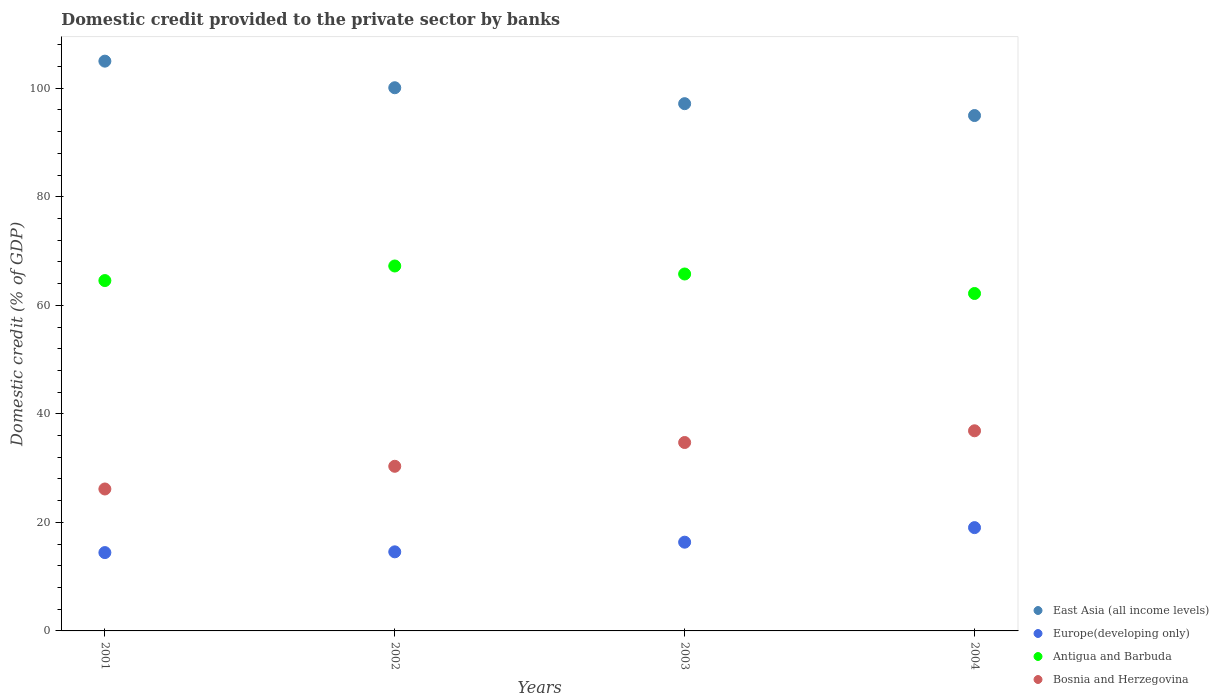Is the number of dotlines equal to the number of legend labels?
Keep it short and to the point. Yes. What is the domestic credit provided to the private sector by banks in East Asia (all income levels) in 2001?
Give a very brief answer. 104.99. Across all years, what is the maximum domestic credit provided to the private sector by banks in Bosnia and Herzegovina?
Keep it short and to the point. 36.88. Across all years, what is the minimum domestic credit provided to the private sector by banks in Europe(developing only)?
Provide a succinct answer. 14.43. In which year was the domestic credit provided to the private sector by banks in East Asia (all income levels) maximum?
Ensure brevity in your answer.  2001. In which year was the domestic credit provided to the private sector by banks in Europe(developing only) minimum?
Keep it short and to the point. 2001. What is the total domestic credit provided to the private sector by banks in Antigua and Barbuda in the graph?
Offer a terse response. 259.74. What is the difference between the domestic credit provided to the private sector by banks in Europe(developing only) in 2002 and that in 2004?
Provide a short and direct response. -4.46. What is the difference between the domestic credit provided to the private sector by banks in Antigua and Barbuda in 2004 and the domestic credit provided to the private sector by banks in Europe(developing only) in 2001?
Your response must be concise. 47.74. What is the average domestic credit provided to the private sector by banks in East Asia (all income levels) per year?
Give a very brief answer. 99.3. In the year 2001, what is the difference between the domestic credit provided to the private sector by banks in Bosnia and Herzegovina and domestic credit provided to the private sector by banks in Europe(developing only)?
Your answer should be very brief. 11.72. In how many years, is the domestic credit provided to the private sector by banks in Bosnia and Herzegovina greater than 40 %?
Provide a short and direct response. 0. What is the ratio of the domestic credit provided to the private sector by banks in Europe(developing only) in 2002 to that in 2004?
Ensure brevity in your answer.  0.77. Is the domestic credit provided to the private sector by banks in Europe(developing only) in 2001 less than that in 2004?
Your answer should be very brief. Yes. Is the difference between the domestic credit provided to the private sector by banks in Bosnia and Herzegovina in 2001 and 2003 greater than the difference between the domestic credit provided to the private sector by banks in Europe(developing only) in 2001 and 2003?
Your answer should be compact. No. What is the difference between the highest and the second highest domestic credit provided to the private sector by banks in East Asia (all income levels)?
Give a very brief answer. 4.9. What is the difference between the highest and the lowest domestic credit provided to the private sector by banks in Europe(developing only)?
Keep it short and to the point. 4.6. Does the domestic credit provided to the private sector by banks in East Asia (all income levels) monotonically increase over the years?
Give a very brief answer. No. Is the domestic credit provided to the private sector by banks in Antigua and Barbuda strictly less than the domestic credit provided to the private sector by banks in Bosnia and Herzegovina over the years?
Keep it short and to the point. No. Are the values on the major ticks of Y-axis written in scientific E-notation?
Give a very brief answer. No. Does the graph contain any zero values?
Make the answer very short. No. Does the graph contain grids?
Offer a very short reply. No. Where does the legend appear in the graph?
Provide a succinct answer. Bottom right. How many legend labels are there?
Offer a very short reply. 4. What is the title of the graph?
Provide a succinct answer. Domestic credit provided to the private sector by banks. Does "Equatorial Guinea" appear as one of the legend labels in the graph?
Ensure brevity in your answer.  No. What is the label or title of the Y-axis?
Your answer should be very brief. Domestic credit (% of GDP). What is the Domestic credit (% of GDP) of East Asia (all income levels) in 2001?
Provide a succinct answer. 104.99. What is the Domestic credit (% of GDP) of Europe(developing only) in 2001?
Keep it short and to the point. 14.43. What is the Domestic credit (% of GDP) in Antigua and Barbuda in 2001?
Provide a short and direct response. 64.56. What is the Domestic credit (% of GDP) in Bosnia and Herzegovina in 2001?
Keep it short and to the point. 26.15. What is the Domestic credit (% of GDP) of East Asia (all income levels) in 2002?
Your response must be concise. 100.09. What is the Domestic credit (% of GDP) of Europe(developing only) in 2002?
Your answer should be compact. 14.57. What is the Domestic credit (% of GDP) in Antigua and Barbuda in 2002?
Provide a succinct answer. 67.24. What is the Domestic credit (% of GDP) of Bosnia and Herzegovina in 2002?
Your answer should be compact. 30.34. What is the Domestic credit (% of GDP) in East Asia (all income levels) in 2003?
Your response must be concise. 97.15. What is the Domestic credit (% of GDP) in Europe(developing only) in 2003?
Your answer should be very brief. 16.35. What is the Domestic credit (% of GDP) of Antigua and Barbuda in 2003?
Make the answer very short. 65.77. What is the Domestic credit (% of GDP) of Bosnia and Herzegovina in 2003?
Your response must be concise. 34.72. What is the Domestic credit (% of GDP) of East Asia (all income levels) in 2004?
Keep it short and to the point. 94.96. What is the Domestic credit (% of GDP) of Europe(developing only) in 2004?
Your response must be concise. 19.03. What is the Domestic credit (% of GDP) in Antigua and Barbuda in 2004?
Your answer should be very brief. 62.18. What is the Domestic credit (% of GDP) of Bosnia and Herzegovina in 2004?
Keep it short and to the point. 36.88. Across all years, what is the maximum Domestic credit (% of GDP) of East Asia (all income levels)?
Your answer should be compact. 104.99. Across all years, what is the maximum Domestic credit (% of GDP) of Europe(developing only)?
Your answer should be very brief. 19.03. Across all years, what is the maximum Domestic credit (% of GDP) of Antigua and Barbuda?
Make the answer very short. 67.24. Across all years, what is the maximum Domestic credit (% of GDP) of Bosnia and Herzegovina?
Keep it short and to the point. 36.88. Across all years, what is the minimum Domestic credit (% of GDP) of East Asia (all income levels)?
Keep it short and to the point. 94.96. Across all years, what is the minimum Domestic credit (% of GDP) in Europe(developing only)?
Provide a succinct answer. 14.43. Across all years, what is the minimum Domestic credit (% of GDP) of Antigua and Barbuda?
Your response must be concise. 62.18. Across all years, what is the minimum Domestic credit (% of GDP) of Bosnia and Herzegovina?
Give a very brief answer. 26.15. What is the total Domestic credit (% of GDP) in East Asia (all income levels) in the graph?
Provide a succinct answer. 397.19. What is the total Domestic credit (% of GDP) of Europe(developing only) in the graph?
Offer a terse response. 64.39. What is the total Domestic credit (% of GDP) of Antigua and Barbuda in the graph?
Provide a succinct answer. 259.74. What is the total Domestic credit (% of GDP) in Bosnia and Herzegovina in the graph?
Offer a terse response. 128.08. What is the difference between the Domestic credit (% of GDP) in East Asia (all income levels) in 2001 and that in 2002?
Provide a short and direct response. 4.9. What is the difference between the Domestic credit (% of GDP) of Europe(developing only) in 2001 and that in 2002?
Ensure brevity in your answer.  -0.14. What is the difference between the Domestic credit (% of GDP) in Antigua and Barbuda in 2001 and that in 2002?
Your answer should be very brief. -2.69. What is the difference between the Domestic credit (% of GDP) of Bosnia and Herzegovina in 2001 and that in 2002?
Keep it short and to the point. -4.18. What is the difference between the Domestic credit (% of GDP) in East Asia (all income levels) in 2001 and that in 2003?
Offer a terse response. 7.84. What is the difference between the Domestic credit (% of GDP) of Europe(developing only) in 2001 and that in 2003?
Provide a succinct answer. -1.92. What is the difference between the Domestic credit (% of GDP) of Antigua and Barbuda in 2001 and that in 2003?
Offer a terse response. -1.21. What is the difference between the Domestic credit (% of GDP) in Bosnia and Herzegovina in 2001 and that in 2003?
Provide a succinct answer. -8.56. What is the difference between the Domestic credit (% of GDP) of East Asia (all income levels) in 2001 and that in 2004?
Provide a succinct answer. 10.02. What is the difference between the Domestic credit (% of GDP) of Europe(developing only) in 2001 and that in 2004?
Provide a succinct answer. -4.6. What is the difference between the Domestic credit (% of GDP) of Antigua and Barbuda in 2001 and that in 2004?
Provide a short and direct response. 2.38. What is the difference between the Domestic credit (% of GDP) of Bosnia and Herzegovina in 2001 and that in 2004?
Your response must be concise. -10.72. What is the difference between the Domestic credit (% of GDP) of East Asia (all income levels) in 2002 and that in 2003?
Offer a terse response. 2.94. What is the difference between the Domestic credit (% of GDP) of Europe(developing only) in 2002 and that in 2003?
Your response must be concise. -1.78. What is the difference between the Domestic credit (% of GDP) in Antigua and Barbuda in 2002 and that in 2003?
Your answer should be very brief. 1.47. What is the difference between the Domestic credit (% of GDP) of Bosnia and Herzegovina in 2002 and that in 2003?
Offer a very short reply. -4.38. What is the difference between the Domestic credit (% of GDP) in East Asia (all income levels) in 2002 and that in 2004?
Your answer should be compact. 5.12. What is the difference between the Domestic credit (% of GDP) in Europe(developing only) in 2002 and that in 2004?
Provide a short and direct response. -4.46. What is the difference between the Domestic credit (% of GDP) of Antigua and Barbuda in 2002 and that in 2004?
Provide a short and direct response. 5.07. What is the difference between the Domestic credit (% of GDP) of Bosnia and Herzegovina in 2002 and that in 2004?
Your answer should be very brief. -6.54. What is the difference between the Domestic credit (% of GDP) of East Asia (all income levels) in 2003 and that in 2004?
Provide a succinct answer. 2.19. What is the difference between the Domestic credit (% of GDP) of Europe(developing only) in 2003 and that in 2004?
Provide a short and direct response. -2.68. What is the difference between the Domestic credit (% of GDP) of Antigua and Barbuda in 2003 and that in 2004?
Your answer should be very brief. 3.59. What is the difference between the Domestic credit (% of GDP) of Bosnia and Herzegovina in 2003 and that in 2004?
Give a very brief answer. -2.16. What is the difference between the Domestic credit (% of GDP) of East Asia (all income levels) in 2001 and the Domestic credit (% of GDP) of Europe(developing only) in 2002?
Ensure brevity in your answer.  90.42. What is the difference between the Domestic credit (% of GDP) in East Asia (all income levels) in 2001 and the Domestic credit (% of GDP) in Antigua and Barbuda in 2002?
Keep it short and to the point. 37.74. What is the difference between the Domestic credit (% of GDP) in East Asia (all income levels) in 2001 and the Domestic credit (% of GDP) in Bosnia and Herzegovina in 2002?
Keep it short and to the point. 74.65. What is the difference between the Domestic credit (% of GDP) of Europe(developing only) in 2001 and the Domestic credit (% of GDP) of Antigua and Barbuda in 2002?
Offer a very short reply. -52.81. What is the difference between the Domestic credit (% of GDP) in Europe(developing only) in 2001 and the Domestic credit (% of GDP) in Bosnia and Herzegovina in 2002?
Offer a terse response. -15.9. What is the difference between the Domestic credit (% of GDP) in Antigua and Barbuda in 2001 and the Domestic credit (% of GDP) in Bosnia and Herzegovina in 2002?
Provide a short and direct response. 34.22. What is the difference between the Domestic credit (% of GDP) of East Asia (all income levels) in 2001 and the Domestic credit (% of GDP) of Europe(developing only) in 2003?
Offer a very short reply. 88.64. What is the difference between the Domestic credit (% of GDP) in East Asia (all income levels) in 2001 and the Domestic credit (% of GDP) in Antigua and Barbuda in 2003?
Ensure brevity in your answer.  39.22. What is the difference between the Domestic credit (% of GDP) of East Asia (all income levels) in 2001 and the Domestic credit (% of GDP) of Bosnia and Herzegovina in 2003?
Offer a terse response. 70.27. What is the difference between the Domestic credit (% of GDP) of Europe(developing only) in 2001 and the Domestic credit (% of GDP) of Antigua and Barbuda in 2003?
Your answer should be compact. -51.33. What is the difference between the Domestic credit (% of GDP) of Europe(developing only) in 2001 and the Domestic credit (% of GDP) of Bosnia and Herzegovina in 2003?
Offer a very short reply. -20.28. What is the difference between the Domestic credit (% of GDP) of Antigua and Barbuda in 2001 and the Domestic credit (% of GDP) of Bosnia and Herzegovina in 2003?
Keep it short and to the point. 29.84. What is the difference between the Domestic credit (% of GDP) in East Asia (all income levels) in 2001 and the Domestic credit (% of GDP) in Europe(developing only) in 2004?
Offer a terse response. 85.95. What is the difference between the Domestic credit (% of GDP) in East Asia (all income levels) in 2001 and the Domestic credit (% of GDP) in Antigua and Barbuda in 2004?
Keep it short and to the point. 42.81. What is the difference between the Domestic credit (% of GDP) in East Asia (all income levels) in 2001 and the Domestic credit (% of GDP) in Bosnia and Herzegovina in 2004?
Offer a terse response. 68.11. What is the difference between the Domestic credit (% of GDP) in Europe(developing only) in 2001 and the Domestic credit (% of GDP) in Antigua and Barbuda in 2004?
Provide a short and direct response. -47.74. What is the difference between the Domestic credit (% of GDP) of Europe(developing only) in 2001 and the Domestic credit (% of GDP) of Bosnia and Herzegovina in 2004?
Give a very brief answer. -22.44. What is the difference between the Domestic credit (% of GDP) of Antigua and Barbuda in 2001 and the Domestic credit (% of GDP) of Bosnia and Herzegovina in 2004?
Provide a short and direct response. 27.68. What is the difference between the Domestic credit (% of GDP) of East Asia (all income levels) in 2002 and the Domestic credit (% of GDP) of Europe(developing only) in 2003?
Your answer should be compact. 83.74. What is the difference between the Domestic credit (% of GDP) in East Asia (all income levels) in 2002 and the Domestic credit (% of GDP) in Antigua and Barbuda in 2003?
Your response must be concise. 34.32. What is the difference between the Domestic credit (% of GDP) of East Asia (all income levels) in 2002 and the Domestic credit (% of GDP) of Bosnia and Herzegovina in 2003?
Keep it short and to the point. 65.37. What is the difference between the Domestic credit (% of GDP) of Europe(developing only) in 2002 and the Domestic credit (% of GDP) of Antigua and Barbuda in 2003?
Provide a short and direct response. -51.2. What is the difference between the Domestic credit (% of GDP) of Europe(developing only) in 2002 and the Domestic credit (% of GDP) of Bosnia and Herzegovina in 2003?
Make the answer very short. -20.15. What is the difference between the Domestic credit (% of GDP) of Antigua and Barbuda in 2002 and the Domestic credit (% of GDP) of Bosnia and Herzegovina in 2003?
Ensure brevity in your answer.  32.53. What is the difference between the Domestic credit (% of GDP) in East Asia (all income levels) in 2002 and the Domestic credit (% of GDP) in Europe(developing only) in 2004?
Provide a short and direct response. 81.06. What is the difference between the Domestic credit (% of GDP) of East Asia (all income levels) in 2002 and the Domestic credit (% of GDP) of Antigua and Barbuda in 2004?
Offer a very short reply. 37.91. What is the difference between the Domestic credit (% of GDP) of East Asia (all income levels) in 2002 and the Domestic credit (% of GDP) of Bosnia and Herzegovina in 2004?
Offer a very short reply. 63.21. What is the difference between the Domestic credit (% of GDP) in Europe(developing only) in 2002 and the Domestic credit (% of GDP) in Antigua and Barbuda in 2004?
Your response must be concise. -47.6. What is the difference between the Domestic credit (% of GDP) of Europe(developing only) in 2002 and the Domestic credit (% of GDP) of Bosnia and Herzegovina in 2004?
Your answer should be very brief. -22.31. What is the difference between the Domestic credit (% of GDP) in Antigua and Barbuda in 2002 and the Domestic credit (% of GDP) in Bosnia and Herzegovina in 2004?
Your answer should be compact. 30.37. What is the difference between the Domestic credit (% of GDP) in East Asia (all income levels) in 2003 and the Domestic credit (% of GDP) in Europe(developing only) in 2004?
Provide a short and direct response. 78.12. What is the difference between the Domestic credit (% of GDP) in East Asia (all income levels) in 2003 and the Domestic credit (% of GDP) in Antigua and Barbuda in 2004?
Give a very brief answer. 34.98. What is the difference between the Domestic credit (% of GDP) of East Asia (all income levels) in 2003 and the Domestic credit (% of GDP) of Bosnia and Herzegovina in 2004?
Offer a terse response. 60.28. What is the difference between the Domestic credit (% of GDP) of Europe(developing only) in 2003 and the Domestic credit (% of GDP) of Antigua and Barbuda in 2004?
Your answer should be compact. -45.82. What is the difference between the Domestic credit (% of GDP) of Europe(developing only) in 2003 and the Domestic credit (% of GDP) of Bosnia and Herzegovina in 2004?
Your answer should be very brief. -20.53. What is the difference between the Domestic credit (% of GDP) in Antigua and Barbuda in 2003 and the Domestic credit (% of GDP) in Bosnia and Herzegovina in 2004?
Your response must be concise. 28.89. What is the average Domestic credit (% of GDP) of East Asia (all income levels) per year?
Give a very brief answer. 99.3. What is the average Domestic credit (% of GDP) of Europe(developing only) per year?
Give a very brief answer. 16.1. What is the average Domestic credit (% of GDP) in Antigua and Barbuda per year?
Offer a very short reply. 64.94. What is the average Domestic credit (% of GDP) of Bosnia and Herzegovina per year?
Provide a short and direct response. 32.02. In the year 2001, what is the difference between the Domestic credit (% of GDP) in East Asia (all income levels) and Domestic credit (% of GDP) in Europe(developing only)?
Give a very brief answer. 90.55. In the year 2001, what is the difference between the Domestic credit (% of GDP) in East Asia (all income levels) and Domestic credit (% of GDP) in Antigua and Barbuda?
Your answer should be compact. 40.43. In the year 2001, what is the difference between the Domestic credit (% of GDP) in East Asia (all income levels) and Domestic credit (% of GDP) in Bosnia and Herzegovina?
Give a very brief answer. 78.83. In the year 2001, what is the difference between the Domestic credit (% of GDP) in Europe(developing only) and Domestic credit (% of GDP) in Antigua and Barbuda?
Provide a succinct answer. -50.12. In the year 2001, what is the difference between the Domestic credit (% of GDP) of Europe(developing only) and Domestic credit (% of GDP) of Bosnia and Herzegovina?
Offer a terse response. -11.72. In the year 2001, what is the difference between the Domestic credit (% of GDP) of Antigua and Barbuda and Domestic credit (% of GDP) of Bosnia and Herzegovina?
Make the answer very short. 38.4. In the year 2002, what is the difference between the Domestic credit (% of GDP) of East Asia (all income levels) and Domestic credit (% of GDP) of Europe(developing only)?
Keep it short and to the point. 85.52. In the year 2002, what is the difference between the Domestic credit (% of GDP) in East Asia (all income levels) and Domestic credit (% of GDP) in Antigua and Barbuda?
Keep it short and to the point. 32.85. In the year 2002, what is the difference between the Domestic credit (% of GDP) in East Asia (all income levels) and Domestic credit (% of GDP) in Bosnia and Herzegovina?
Offer a very short reply. 69.75. In the year 2002, what is the difference between the Domestic credit (% of GDP) of Europe(developing only) and Domestic credit (% of GDP) of Antigua and Barbuda?
Provide a succinct answer. -52.67. In the year 2002, what is the difference between the Domestic credit (% of GDP) of Europe(developing only) and Domestic credit (% of GDP) of Bosnia and Herzegovina?
Offer a terse response. -15.76. In the year 2002, what is the difference between the Domestic credit (% of GDP) of Antigua and Barbuda and Domestic credit (% of GDP) of Bosnia and Herzegovina?
Provide a succinct answer. 36.91. In the year 2003, what is the difference between the Domestic credit (% of GDP) of East Asia (all income levels) and Domestic credit (% of GDP) of Europe(developing only)?
Your response must be concise. 80.8. In the year 2003, what is the difference between the Domestic credit (% of GDP) in East Asia (all income levels) and Domestic credit (% of GDP) in Antigua and Barbuda?
Offer a very short reply. 31.38. In the year 2003, what is the difference between the Domestic credit (% of GDP) in East Asia (all income levels) and Domestic credit (% of GDP) in Bosnia and Herzegovina?
Keep it short and to the point. 62.44. In the year 2003, what is the difference between the Domestic credit (% of GDP) of Europe(developing only) and Domestic credit (% of GDP) of Antigua and Barbuda?
Offer a terse response. -49.42. In the year 2003, what is the difference between the Domestic credit (% of GDP) in Europe(developing only) and Domestic credit (% of GDP) in Bosnia and Herzegovina?
Provide a short and direct response. -18.37. In the year 2003, what is the difference between the Domestic credit (% of GDP) in Antigua and Barbuda and Domestic credit (% of GDP) in Bosnia and Herzegovina?
Provide a short and direct response. 31.05. In the year 2004, what is the difference between the Domestic credit (% of GDP) in East Asia (all income levels) and Domestic credit (% of GDP) in Europe(developing only)?
Provide a short and direct response. 75.93. In the year 2004, what is the difference between the Domestic credit (% of GDP) of East Asia (all income levels) and Domestic credit (% of GDP) of Antigua and Barbuda?
Offer a very short reply. 32.79. In the year 2004, what is the difference between the Domestic credit (% of GDP) in East Asia (all income levels) and Domestic credit (% of GDP) in Bosnia and Herzegovina?
Your answer should be very brief. 58.09. In the year 2004, what is the difference between the Domestic credit (% of GDP) in Europe(developing only) and Domestic credit (% of GDP) in Antigua and Barbuda?
Offer a very short reply. -43.14. In the year 2004, what is the difference between the Domestic credit (% of GDP) in Europe(developing only) and Domestic credit (% of GDP) in Bosnia and Herzegovina?
Your answer should be compact. -17.84. In the year 2004, what is the difference between the Domestic credit (% of GDP) of Antigua and Barbuda and Domestic credit (% of GDP) of Bosnia and Herzegovina?
Offer a very short reply. 25.3. What is the ratio of the Domestic credit (% of GDP) in East Asia (all income levels) in 2001 to that in 2002?
Offer a terse response. 1.05. What is the ratio of the Domestic credit (% of GDP) in Antigua and Barbuda in 2001 to that in 2002?
Keep it short and to the point. 0.96. What is the ratio of the Domestic credit (% of GDP) of Bosnia and Herzegovina in 2001 to that in 2002?
Ensure brevity in your answer.  0.86. What is the ratio of the Domestic credit (% of GDP) of East Asia (all income levels) in 2001 to that in 2003?
Provide a succinct answer. 1.08. What is the ratio of the Domestic credit (% of GDP) in Europe(developing only) in 2001 to that in 2003?
Your response must be concise. 0.88. What is the ratio of the Domestic credit (% of GDP) of Antigua and Barbuda in 2001 to that in 2003?
Give a very brief answer. 0.98. What is the ratio of the Domestic credit (% of GDP) of Bosnia and Herzegovina in 2001 to that in 2003?
Ensure brevity in your answer.  0.75. What is the ratio of the Domestic credit (% of GDP) in East Asia (all income levels) in 2001 to that in 2004?
Ensure brevity in your answer.  1.11. What is the ratio of the Domestic credit (% of GDP) in Europe(developing only) in 2001 to that in 2004?
Provide a short and direct response. 0.76. What is the ratio of the Domestic credit (% of GDP) of Antigua and Barbuda in 2001 to that in 2004?
Your answer should be very brief. 1.04. What is the ratio of the Domestic credit (% of GDP) in Bosnia and Herzegovina in 2001 to that in 2004?
Your answer should be compact. 0.71. What is the ratio of the Domestic credit (% of GDP) in East Asia (all income levels) in 2002 to that in 2003?
Make the answer very short. 1.03. What is the ratio of the Domestic credit (% of GDP) in Europe(developing only) in 2002 to that in 2003?
Your answer should be compact. 0.89. What is the ratio of the Domestic credit (% of GDP) in Antigua and Barbuda in 2002 to that in 2003?
Make the answer very short. 1.02. What is the ratio of the Domestic credit (% of GDP) of Bosnia and Herzegovina in 2002 to that in 2003?
Provide a succinct answer. 0.87. What is the ratio of the Domestic credit (% of GDP) in East Asia (all income levels) in 2002 to that in 2004?
Your response must be concise. 1.05. What is the ratio of the Domestic credit (% of GDP) in Europe(developing only) in 2002 to that in 2004?
Offer a very short reply. 0.77. What is the ratio of the Domestic credit (% of GDP) of Antigua and Barbuda in 2002 to that in 2004?
Provide a short and direct response. 1.08. What is the ratio of the Domestic credit (% of GDP) of Bosnia and Herzegovina in 2002 to that in 2004?
Provide a succinct answer. 0.82. What is the ratio of the Domestic credit (% of GDP) in Europe(developing only) in 2003 to that in 2004?
Your response must be concise. 0.86. What is the ratio of the Domestic credit (% of GDP) in Antigua and Barbuda in 2003 to that in 2004?
Your answer should be very brief. 1.06. What is the ratio of the Domestic credit (% of GDP) in Bosnia and Herzegovina in 2003 to that in 2004?
Provide a short and direct response. 0.94. What is the difference between the highest and the second highest Domestic credit (% of GDP) in East Asia (all income levels)?
Provide a succinct answer. 4.9. What is the difference between the highest and the second highest Domestic credit (% of GDP) of Europe(developing only)?
Make the answer very short. 2.68. What is the difference between the highest and the second highest Domestic credit (% of GDP) of Antigua and Barbuda?
Your response must be concise. 1.47. What is the difference between the highest and the second highest Domestic credit (% of GDP) of Bosnia and Herzegovina?
Provide a succinct answer. 2.16. What is the difference between the highest and the lowest Domestic credit (% of GDP) of East Asia (all income levels)?
Make the answer very short. 10.02. What is the difference between the highest and the lowest Domestic credit (% of GDP) of Europe(developing only)?
Your answer should be very brief. 4.6. What is the difference between the highest and the lowest Domestic credit (% of GDP) in Antigua and Barbuda?
Make the answer very short. 5.07. What is the difference between the highest and the lowest Domestic credit (% of GDP) in Bosnia and Herzegovina?
Provide a succinct answer. 10.72. 